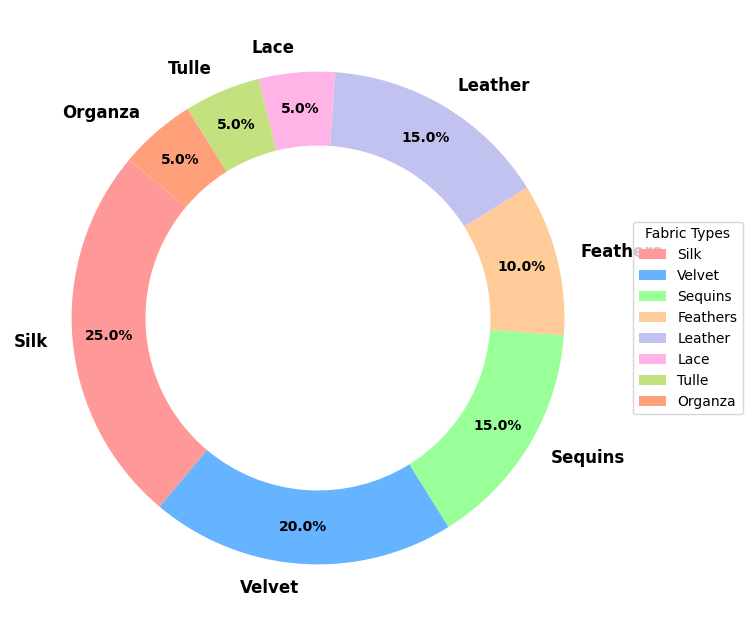What is the most common fabric type used in extravagant illusionist outfits? To determine the most common fabric type, look for the segment with the largest percentage in the pie chart. Here, Silk has the largest portion at 25%.
Answer: Silk Which fabric type is used more, Velvet or Sequins? Compare the segments for Velvet and Sequins in the chart. Velvet makes up 20%, whereas Sequins are 15%. Velvet has a higher percentage.
Answer: Velvet What is the combined percentage of fabrics Silk and Velvet used in extravagant illusionist outfits? Add the percentages of Silk and Velvet together. Silk is 25% and Velvet is 20%. So, 25% + 20% = 45%.
Answer: 45% Are Feathers used more than Tulle and Organza combined? Compare the individual percentage for Feathers with the combined percentages for Tulle and Organza. Feathers are 10%, while Tulle and Organza are both 5% each, making it 10% total for Tulle and Organza combined. They are equal.
Answer: No Which fabric types are used the least in extravagant illusionist outfits? Identify the segments with the smallest percentages. Lace, Tulle, and Organza each have 5% which are the smallest percentages.
Answer: Lace, Tulle, Organza How much more of Silk is used compared to Feathers? Subtract the percentage of Feathers from the percentage of Silk. Silk is 25% and Feathers are 10%. Therefore, 25% - 10% = 15%.
Answer: 15% What is the percentage difference between the usage of Sequins and Leather? Calculate the absolute difference between the two percentages. Sequins are 15% and Leather is also 15%, so the difference is 0%.
Answer: 0% What is the average percentage use across all fabric types used in the chart? Sum all the percentages and divide by the number of fabric types. Total of percentages: 25 + 20 + 15 + 10 + 15 + 5 + 5 + 5 = 100%. Number of fabric types: 8. Average = 100% / 8 = 12.5%.
Answer: 12.5% What is the sum of the percentages for the three least common fabric types? Sum the percentages for the smallest slices: Lace, Tulle, and Organza, each 5%. So, 5% + 5% + 5% = 15%.
Answer: 15% 